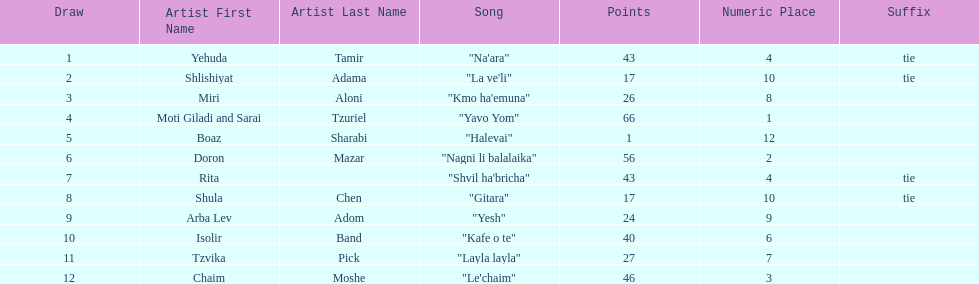How many points does the artist rita have? 43. 